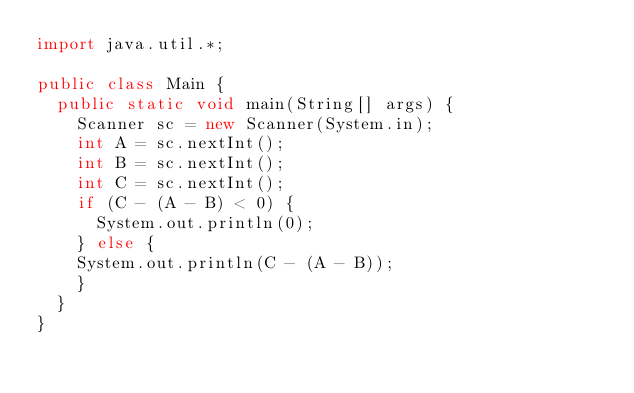<code> <loc_0><loc_0><loc_500><loc_500><_Java_>import java.util.*;

public class Main {
  public static void main(String[] args) {
    Scanner sc = new Scanner(System.in);
    int A = sc.nextInt();
    int B = sc.nextInt();
    int C = sc.nextInt();
    if (C - (A - B) < 0) {
      System.out.println(0);
    } else { 
    System.out.println(C - (A - B));
    }
  }
}</code> 